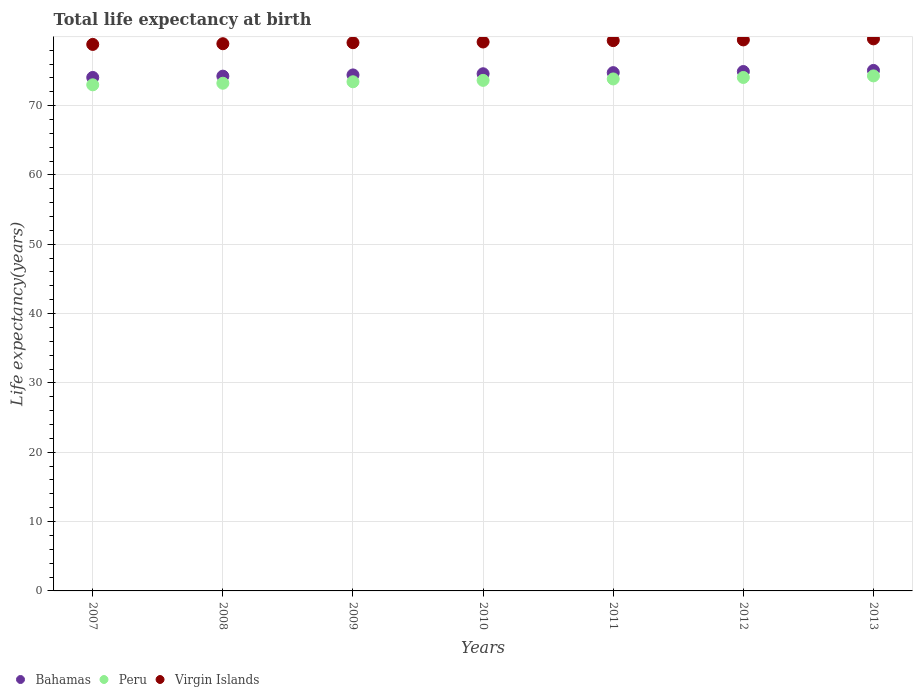How many different coloured dotlines are there?
Your answer should be very brief. 3. Is the number of dotlines equal to the number of legend labels?
Ensure brevity in your answer.  Yes. What is the life expectancy at birth in in Bahamas in 2009?
Offer a very short reply. 74.42. Across all years, what is the maximum life expectancy at birth in in Bahamas?
Your answer should be very brief. 75.07. Across all years, what is the minimum life expectancy at birth in in Bahamas?
Provide a short and direct response. 74.06. In which year was the life expectancy at birth in in Virgin Islands maximum?
Give a very brief answer. 2013. In which year was the life expectancy at birth in in Bahamas minimum?
Offer a very short reply. 2007. What is the total life expectancy at birth in in Bahamas in the graph?
Your answer should be very brief. 522.07. What is the difference between the life expectancy at birth in in Virgin Islands in 2007 and that in 2009?
Your answer should be very brief. -0.25. What is the difference between the life expectancy at birth in in Peru in 2013 and the life expectancy at birth in in Virgin Islands in 2009?
Your response must be concise. -4.79. What is the average life expectancy at birth in in Virgin Islands per year?
Your response must be concise. 79.21. In the year 2008, what is the difference between the life expectancy at birth in in Virgin Islands and life expectancy at birth in in Bahamas?
Offer a very short reply. 4.68. In how many years, is the life expectancy at birth in in Peru greater than 58 years?
Provide a short and direct response. 7. What is the ratio of the life expectancy at birth in in Bahamas in 2007 to that in 2013?
Provide a succinct answer. 0.99. Is the life expectancy at birth in in Bahamas in 2010 less than that in 2013?
Provide a succinct answer. Yes. Is the difference between the life expectancy at birth in in Virgin Islands in 2009 and 2011 greater than the difference between the life expectancy at birth in in Bahamas in 2009 and 2011?
Your response must be concise. Yes. What is the difference between the highest and the second highest life expectancy at birth in in Virgin Islands?
Keep it short and to the point. 0.15. What is the difference between the highest and the lowest life expectancy at birth in in Peru?
Provide a succinct answer. 1.29. Is the sum of the life expectancy at birth in in Virgin Islands in 2009 and 2012 greater than the maximum life expectancy at birth in in Peru across all years?
Your answer should be compact. Yes. Is it the case that in every year, the sum of the life expectancy at birth in in Virgin Islands and life expectancy at birth in in Peru  is greater than the life expectancy at birth in in Bahamas?
Offer a terse response. Yes. Is the life expectancy at birth in in Virgin Islands strictly greater than the life expectancy at birth in in Peru over the years?
Keep it short and to the point. Yes. How many years are there in the graph?
Provide a short and direct response. 7. Are the values on the major ticks of Y-axis written in scientific E-notation?
Your answer should be very brief. No. Does the graph contain any zero values?
Ensure brevity in your answer.  No. Does the graph contain grids?
Provide a short and direct response. Yes. Where does the legend appear in the graph?
Make the answer very short. Bottom left. How many legend labels are there?
Your response must be concise. 3. How are the legend labels stacked?
Offer a terse response. Horizontal. What is the title of the graph?
Make the answer very short. Total life expectancy at birth. Does "Australia" appear as one of the legend labels in the graph?
Give a very brief answer. No. What is the label or title of the Y-axis?
Your answer should be compact. Life expectancy(years). What is the Life expectancy(years) in Bahamas in 2007?
Offer a very short reply. 74.06. What is the Life expectancy(years) of Peru in 2007?
Provide a short and direct response. 73. What is the Life expectancy(years) in Virgin Islands in 2007?
Your answer should be compact. 78.82. What is the Life expectancy(years) in Bahamas in 2008?
Give a very brief answer. 74.25. What is the Life expectancy(years) of Peru in 2008?
Your answer should be very brief. 73.23. What is the Life expectancy(years) of Virgin Islands in 2008?
Your answer should be compact. 78.92. What is the Life expectancy(years) in Bahamas in 2009?
Provide a succinct answer. 74.42. What is the Life expectancy(years) in Peru in 2009?
Give a very brief answer. 73.44. What is the Life expectancy(years) in Virgin Islands in 2009?
Give a very brief answer. 79.07. What is the Life expectancy(years) of Bahamas in 2010?
Offer a very short reply. 74.59. What is the Life expectancy(years) of Peru in 2010?
Ensure brevity in your answer.  73.64. What is the Life expectancy(years) of Virgin Islands in 2010?
Give a very brief answer. 79.17. What is the Life expectancy(years) in Bahamas in 2011?
Keep it short and to the point. 74.75. What is the Life expectancy(years) of Peru in 2011?
Your answer should be very brief. 73.84. What is the Life expectancy(years) in Virgin Islands in 2011?
Give a very brief answer. 79.37. What is the Life expectancy(years) in Bahamas in 2012?
Your answer should be very brief. 74.91. What is the Life expectancy(years) in Peru in 2012?
Give a very brief answer. 74.06. What is the Life expectancy(years) of Virgin Islands in 2012?
Make the answer very short. 79.47. What is the Life expectancy(years) in Bahamas in 2013?
Give a very brief answer. 75.07. What is the Life expectancy(years) of Peru in 2013?
Provide a succinct answer. 74.28. What is the Life expectancy(years) of Virgin Islands in 2013?
Provide a short and direct response. 79.62. Across all years, what is the maximum Life expectancy(years) of Bahamas?
Provide a succinct answer. 75.07. Across all years, what is the maximum Life expectancy(years) of Peru?
Give a very brief answer. 74.28. Across all years, what is the maximum Life expectancy(years) of Virgin Islands?
Give a very brief answer. 79.62. Across all years, what is the minimum Life expectancy(years) in Bahamas?
Your answer should be compact. 74.06. Across all years, what is the minimum Life expectancy(years) of Peru?
Provide a succinct answer. 73. Across all years, what is the minimum Life expectancy(years) of Virgin Islands?
Offer a very short reply. 78.82. What is the total Life expectancy(years) of Bahamas in the graph?
Offer a terse response. 522.07. What is the total Life expectancy(years) in Peru in the graph?
Your answer should be very brief. 515.48. What is the total Life expectancy(years) in Virgin Islands in the graph?
Your answer should be very brief. 554.47. What is the difference between the Life expectancy(years) in Bahamas in 2007 and that in 2008?
Offer a terse response. -0.19. What is the difference between the Life expectancy(years) in Peru in 2007 and that in 2008?
Give a very brief answer. -0.23. What is the difference between the Life expectancy(years) in Virgin Islands in 2007 and that in 2008?
Your answer should be compact. -0.1. What is the difference between the Life expectancy(years) of Bahamas in 2007 and that in 2009?
Provide a short and direct response. -0.36. What is the difference between the Life expectancy(years) in Peru in 2007 and that in 2009?
Ensure brevity in your answer.  -0.44. What is the difference between the Life expectancy(years) of Virgin Islands in 2007 and that in 2009?
Give a very brief answer. -0.25. What is the difference between the Life expectancy(years) of Bahamas in 2007 and that in 2010?
Provide a succinct answer. -0.53. What is the difference between the Life expectancy(years) of Peru in 2007 and that in 2010?
Make the answer very short. -0.64. What is the difference between the Life expectancy(years) of Virgin Islands in 2007 and that in 2010?
Give a very brief answer. -0.35. What is the difference between the Life expectancy(years) of Bahamas in 2007 and that in 2011?
Your answer should be very brief. -0.69. What is the difference between the Life expectancy(years) in Peru in 2007 and that in 2011?
Offer a very short reply. -0.85. What is the difference between the Life expectancy(years) in Virgin Islands in 2007 and that in 2011?
Your answer should be compact. -0.55. What is the difference between the Life expectancy(years) in Bahamas in 2007 and that in 2012?
Your answer should be very brief. -0.85. What is the difference between the Life expectancy(years) of Peru in 2007 and that in 2012?
Your response must be concise. -1.06. What is the difference between the Life expectancy(years) in Virgin Islands in 2007 and that in 2012?
Your answer should be compact. -0.65. What is the difference between the Life expectancy(years) in Bahamas in 2007 and that in 2013?
Give a very brief answer. -1.01. What is the difference between the Life expectancy(years) in Peru in 2007 and that in 2013?
Provide a succinct answer. -1.29. What is the difference between the Life expectancy(years) in Bahamas in 2008 and that in 2009?
Keep it short and to the point. -0.18. What is the difference between the Life expectancy(years) of Peru in 2008 and that in 2009?
Your answer should be very brief. -0.21. What is the difference between the Life expectancy(years) of Virgin Islands in 2008 and that in 2009?
Offer a very short reply. -0.15. What is the difference between the Life expectancy(years) of Bahamas in 2008 and that in 2010?
Ensure brevity in your answer.  -0.34. What is the difference between the Life expectancy(years) in Peru in 2008 and that in 2010?
Your response must be concise. -0.41. What is the difference between the Life expectancy(years) of Virgin Islands in 2008 and that in 2010?
Provide a succinct answer. -0.25. What is the difference between the Life expectancy(years) in Bahamas in 2008 and that in 2011?
Offer a terse response. -0.51. What is the difference between the Life expectancy(years) in Peru in 2008 and that in 2011?
Offer a terse response. -0.62. What is the difference between the Life expectancy(years) of Virgin Islands in 2008 and that in 2011?
Your answer should be compact. -0.45. What is the difference between the Life expectancy(years) in Bahamas in 2008 and that in 2012?
Offer a terse response. -0.67. What is the difference between the Life expectancy(years) in Peru in 2008 and that in 2012?
Offer a terse response. -0.83. What is the difference between the Life expectancy(years) of Virgin Islands in 2008 and that in 2012?
Provide a succinct answer. -0.55. What is the difference between the Life expectancy(years) in Bahamas in 2008 and that in 2013?
Offer a terse response. -0.83. What is the difference between the Life expectancy(years) of Peru in 2008 and that in 2013?
Offer a terse response. -1.06. What is the difference between the Life expectancy(years) in Virgin Islands in 2008 and that in 2013?
Make the answer very short. -0.7. What is the difference between the Life expectancy(years) in Bahamas in 2009 and that in 2010?
Ensure brevity in your answer.  -0.17. What is the difference between the Life expectancy(years) of Peru in 2009 and that in 2010?
Give a very brief answer. -0.2. What is the difference between the Life expectancy(years) in Virgin Islands in 2009 and that in 2010?
Ensure brevity in your answer.  -0.1. What is the difference between the Life expectancy(years) of Bahamas in 2009 and that in 2011?
Give a very brief answer. -0.33. What is the difference between the Life expectancy(years) of Peru in 2009 and that in 2011?
Offer a very short reply. -0.41. What is the difference between the Life expectancy(years) in Virgin Islands in 2009 and that in 2011?
Offer a terse response. -0.3. What is the difference between the Life expectancy(years) in Bahamas in 2009 and that in 2012?
Provide a short and direct response. -0.49. What is the difference between the Life expectancy(years) of Peru in 2009 and that in 2012?
Ensure brevity in your answer.  -0.62. What is the difference between the Life expectancy(years) in Virgin Islands in 2009 and that in 2012?
Keep it short and to the point. -0.4. What is the difference between the Life expectancy(years) in Bahamas in 2009 and that in 2013?
Ensure brevity in your answer.  -0.65. What is the difference between the Life expectancy(years) in Peru in 2009 and that in 2013?
Ensure brevity in your answer.  -0.85. What is the difference between the Life expectancy(years) of Virgin Islands in 2009 and that in 2013?
Your response must be concise. -0.55. What is the difference between the Life expectancy(years) of Bahamas in 2010 and that in 2011?
Offer a very short reply. -0.16. What is the difference between the Life expectancy(years) in Peru in 2010 and that in 2011?
Offer a terse response. -0.21. What is the difference between the Life expectancy(years) of Virgin Islands in 2010 and that in 2011?
Your answer should be compact. -0.2. What is the difference between the Life expectancy(years) in Bahamas in 2010 and that in 2012?
Your answer should be compact. -0.32. What is the difference between the Life expectancy(years) in Peru in 2010 and that in 2012?
Offer a very short reply. -0.42. What is the difference between the Life expectancy(years) of Bahamas in 2010 and that in 2013?
Your response must be concise. -0.48. What is the difference between the Life expectancy(years) in Peru in 2010 and that in 2013?
Your answer should be compact. -0.64. What is the difference between the Life expectancy(years) in Virgin Islands in 2010 and that in 2013?
Your answer should be compact. -0.45. What is the difference between the Life expectancy(years) in Bahamas in 2011 and that in 2012?
Offer a terse response. -0.16. What is the difference between the Life expectancy(years) in Peru in 2011 and that in 2012?
Keep it short and to the point. -0.21. What is the difference between the Life expectancy(years) in Bahamas in 2011 and that in 2013?
Offer a terse response. -0.32. What is the difference between the Life expectancy(years) of Peru in 2011 and that in 2013?
Your answer should be very brief. -0.44. What is the difference between the Life expectancy(years) of Virgin Islands in 2011 and that in 2013?
Ensure brevity in your answer.  -0.25. What is the difference between the Life expectancy(years) of Bahamas in 2012 and that in 2013?
Provide a succinct answer. -0.16. What is the difference between the Life expectancy(years) in Peru in 2012 and that in 2013?
Give a very brief answer. -0.23. What is the difference between the Life expectancy(years) in Virgin Islands in 2012 and that in 2013?
Keep it short and to the point. -0.15. What is the difference between the Life expectancy(years) of Bahamas in 2007 and the Life expectancy(years) of Peru in 2008?
Your answer should be very brief. 0.83. What is the difference between the Life expectancy(years) in Bahamas in 2007 and the Life expectancy(years) in Virgin Islands in 2008?
Give a very brief answer. -4.86. What is the difference between the Life expectancy(years) in Peru in 2007 and the Life expectancy(years) in Virgin Islands in 2008?
Offer a very short reply. -5.93. What is the difference between the Life expectancy(years) of Bahamas in 2007 and the Life expectancy(years) of Peru in 2009?
Your response must be concise. 0.62. What is the difference between the Life expectancy(years) of Bahamas in 2007 and the Life expectancy(years) of Virgin Islands in 2009?
Offer a terse response. -5.01. What is the difference between the Life expectancy(years) of Peru in 2007 and the Life expectancy(years) of Virgin Islands in 2009?
Provide a short and direct response. -6.08. What is the difference between the Life expectancy(years) of Bahamas in 2007 and the Life expectancy(years) of Peru in 2010?
Your response must be concise. 0.42. What is the difference between the Life expectancy(years) in Bahamas in 2007 and the Life expectancy(years) in Virgin Islands in 2010?
Keep it short and to the point. -5.11. What is the difference between the Life expectancy(years) of Peru in 2007 and the Life expectancy(years) of Virgin Islands in 2010?
Keep it short and to the point. -6.18. What is the difference between the Life expectancy(years) of Bahamas in 2007 and the Life expectancy(years) of Peru in 2011?
Ensure brevity in your answer.  0.21. What is the difference between the Life expectancy(years) in Bahamas in 2007 and the Life expectancy(years) in Virgin Islands in 2011?
Keep it short and to the point. -5.31. What is the difference between the Life expectancy(years) in Peru in 2007 and the Life expectancy(years) in Virgin Islands in 2011?
Offer a very short reply. -6.38. What is the difference between the Life expectancy(years) in Bahamas in 2007 and the Life expectancy(years) in Peru in 2012?
Give a very brief answer. 0. What is the difference between the Life expectancy(years) in Bahamas in 2007 and the Life expectancy(years) in Virgin Islands in 2012?
Keep it short and to the point. -5.41. What is the difference between the Life expectancy(years) of Peru in 2007 and the Life expectancy(years) of Virgin Islands in 2012?
Ensure brevity in your answer.  -6.48. What is the difference between the Life expectancy(years) of Bahamas in 2007 and the Life expectancy(years) of Peru in 2013?
Provide a short and direct response. -0.22. What is the difference between the Life expectancy(years) of Bahamas in 2007 and the Life expectancy(years) of Virgin Islands in 2013?
Make the answer very short. -5.56. What is the difference between the Life expectancy(years) in Peru in 2007 and the Life expectancy(years) in Virgin Islands in 2013?
Your answer should be compact. -6.63. What is the difference between the Life expectancy(years) in Bahamas in 2008 and the Life expectancy(years) in Peru in 2009?
Provide a short and direct response. 0.81. What is the difference between the Life expectancy(years) of Bahamas in 2008 and the Life expectancy(years) of Virgin Islands in 2009?
Your answer should be very brief. -4.83. What is the difference between the Life expectancy(years) in Peru in 2008 and the Life expectancy(years) in Virgin Islands in 2009?
Keep it short and to the point. -5.85. What is the difference between the Life expectancy(years) in Bahamas in 2008 and the Life expectancy(years) in Peru in 2010?
Ensure brevity in your answer.  0.61. What is the difference between the Life expectancy(years) of Bahamas in 2008 and the Life expectancy(years) of Virgin Islands in 2010?
Your response must be concise. -4.93. What is the difference between the Life expectancy(years) in Peru in 2008 and the Life expectancy(years) in Virgin Islands in 2010?
Provide a succinct answer. -5.95. What is the difference between the Life expectancy(years) in Bahamas in 2008 and the Life expectancy(years) in Peru in 2011?
Offer a terse response. 0.4. What is the difference between the Life expectancy(years) of Bahamas in 2008 and the Life expectancy(years) of Virgin Islands in 2011?
Provide a succinct answer. -5.13. What is the difference between the Life expectancy(years) in Peru in 2008 and the Life expectancy(years) in Virgin Islands in 2011?
Give a very brief answer. -6.15. What is the difference between the Life expectancy(years) in Bahamas in 2008 and the Life expectancy(years) in Peru in 2012?
Provide a short and direct response. 0.19. What is the difference between the Life expectancy(years) in Bahamas in 2008 and the Life expectancy(years) in Virgin Islands in 2012?
Keep it short and to the point. -5.23. What is the difference between the Life expectancy(years) of Peru in 2008 and the Life expectancy(years) of Virgin Islands in 2012?
Give a very brief answer. -6.25. What is the difference between the Life expectancy(years) of Bahamas in 2008 and the Life expectancy(years) of Peru in 2013?
Give a very brief answer. -0.04. What is the difference between the Life expectancy(years) of Bahamas in 2008 and the Life expectancy(years) of Virgin Islands in 2013?
Your answer should be very brief. -5.38. What is the difference between the Life expectancy(years) of Peru in 2008 and the Life expectancy(years) of Virgin Islands in 2013?
Provide a succinct answer. -6.4. What is the difference between the Life expectancy(years) of Bahamas in 2009 and the Life expectancy(years) of Peru in 2010?
Your response must be concise. 0.78. What is the difference between the Life expectancy(years) in Bahamas in 2009 and the Life expectancy(years) in Virgin Islands in 2010?
Your answer should be very brief. -4.75. What is the difference between the Life expectancy(years) of Peru in 2009 and the Life expectancy(years) of Virgin Islands in 2010?
Give a very brief answer. -5.74. What is the difference between the Life expectancy(years) of Bahamas in 2009 and the Life expectancy(years) of Peru in 2011?
Your answer should be compact. 0.58. What is the difference between the Life expectancy(years) of Bahamas in 2009 and the Life expectancy(years) of Virgin Islands in 2011?
Your response must be concise. -4.95. What is the difference between the Life expectancy(years) in Peru in 2009 and the Life expectancy(years) in Virgin Islands in 2011?
Provide a short and direct response. -5.94. What is the difference between the Life expectancy(years) of Bahamas in 2009 and the Life expectancy(years) of Peru in 2012?
Ensure brevity in your answer.  0.37. What is the difference between the Life expectancy(years) of Bahamas in 2009 and the Life expectancy(years) of Virgin Islands in 2012?
Offer a very short reply. -5.05. What is the difference between the Life expectancy(years) of Peru in 2009 and the Life expectancy(years) of Virgin Islands in 2012?
Provide a succinct answer. -6.04. What is the difference between the Life expectancy(years) in Bahamas in 2009 and the Life expectancy(years) in Peru in 2013?
Offer a very short reply. 0.14. What is the difference between the Life expectancy(years) of Bahamas in 2009 and the Life expectancy(years) of Virgin Islands in 2013?
Offer a terse response. -5.2. What is the difference between the Life expectancy(years) of Peru in 2009 and the Life expectancy(years) of Virgin Islands in 2013?
Your answer should be very brief. -6.19. What is the difference between the Life expectancy(years) of Bahamas in 2010 and the Life expectancy(years) of Peru in 2011?
Provide a short and direct response. 0.75. What is the difference between the Life expectancy(years) of Bahamas in 2010 and the Life expectancy(years) of Virgin Islands in 2011?
Ensure brevity in your answer.  -4.78. What is the difference between the Life expectancy(years) of Peru in 2010 and the Life expectancy(years) of Virgin Islands in 2011?
Keep it short and to the point. -5.73. What is the difference between the Life expectancy(years) in Bahamas in 2010 and the Life expectancy(years) in Peru in 2012?
Make the answer very short. 0.53. What is the difference between the Life expectancy(years) in Bahamas in 2010 and the Life expectancy(years) in Virgin Islands in 2012?
Make the answer very short. -4.88. What is the difference between the Life expectancy(years) in Peru in 2010 and the Life expectancy(years) in Virgin Islands in 2012?
Your response must be concise. -5.83. What is the difference between the Life expectancy(years) in Bahamas in 2010 and the Life expectancy(years) in Peru in 2013?
Ensure brevity in your answer.  0.31. What is the difference between the Life expectancy(years) of Bahamas in 2010 and the Life expectancy(years) of Virgin Islands in 2013?
Your answer should be very brief. -5.03. What is the difference between the Life expectancy(years) of Peru in 2010 and the Life expectancy(years) of Virgin Islands in 2013?
Provide a short and direct response. -5.98. What is the difference between the Life expectancy(years) of Bahamas in 2011 and the Life expectancy(years) of Peru in 2012?
Offer a very short reply. 0.7. What is the difference between the Life expectancy(years) of Bahamas in 2011 and the Life expectancy(years) of Virgin Islands in 2012?
Your response must be concise. -4.72. What is the difference between the Life expectancy(years) in Peru in 2011 and the Life expectancy(years) in Virgin Islands in 2012?
Make the answer very short. -5.63. What is the difference between the Life expectancy(years) of Bahamas in 2011 and the Life expectancy(years) of Peru in 2013?
Provide a short and direct response. 0.47. What is the difference between the Life expectancy(years) in Bahamas in 2011 and the Life expectancy(years) in Virgin Islands in 2013?
Give a very brief answer. -4.87. What is the difference between the Life expectancy(years) of Peru in 2011 and the Life expectancy(years) of Virgin Islands in 2013?
Give a very brief answer. -5.78. What is the difference between the Life expectancy(years) of Bahamas in 2012 and the Life expectancy(years) of Peru in 2013?
Offer a very short reply. 0.63. What is the difference between the Life expectancy(years) of Bahamas in 2012 and the Life expectancy(years) of Virgin Islands in 2013?
Your answer should be very brief. -4.71. What is the difference between the Life expectancy(years) of Peru in 2012 and the Life expectancy(years) of Virgin Islands in 2013?
Offer a terse response. -5.57. What is the average Life expectancy(years) in Bahamas per year?
Keep it short and to the point. 74.58. What is the average Life expectancy(years) of Peru per year?
Keep it short and to the point. 73.64. What is the average Life expectancy(years) in Virgin Islands per year?
Offer a very short reply. 79.21. In the year 2007, what is the difference between the Life expectancy(years) of Bahamas and Life expectancy(years) of Virgin Islands?
Provide a short and direct response. -4.76. In the year 2007, what is the difference between the Life expectancy(years) in Peru and Life expectancy(years) in Virgin Islands?
Provide a succinct answer. -5.83. In the year 2008, what is the difference between the Life expectancy(years) in Bahamas and Life expectancy(years) in Peru?
Keep it short and to the point. 1.02. In the year 2008, what is the difference between the Life expectancy(years) of Bahamas and Life expectancy(years) of Virgin Islands?
Your response must be concise. -4.68. In the year 2008, what is the difference between the Life expectancy(years) in Peru and Life expectancy(years) in Virgin Islands?
Offer a very short reply. -5.7. In the year 2009, what is the difference between the Life expectancy(years) of Bahamas and Life expectancy(years) of Virgin Islands?
Give a very brief answer. -4.65. In the year 2009, what is the difference between the Life expectancy(years) in Peru and Life expectancy(years) in Virgin Islands?
Your response must be concise. -5.64. In the year 2010, what is the difference between the Life expectancy(years) of Bahamas and Life expectancy(years) of Peru?
Provide a short and direct response. 0.95. In the year 2010, what is the difference between the Life expectancy(years) in Bahamas and Life expectancy(years) in Virgin Islands?
Keep it short and to the point. -4.58. In the year 2010, what is the difference between the Life expectancy(years) of Peru and Life expectancy(years) of Virgin Islands?
Your answer should be compact. -5.53. In the year 2011, what is the difference between the Life expectancy(years) in Bahamas and Life expectancy(years) in Peru?
Make the answer very short. 0.91. In the year 2011, what is the difference between the Life expectancy(years) of Bahamas and Life expectancy(years) of Virgin Islands?
Your answer should be compact. -4.62. In the year 2011, what is the difference between the Life expectancy(years) of Peru and Life expectancy(years) of Virgin Islands?
Make the answer very short. -5.53. In the year 2012, what is the difference between the Life expectancy(years) of Bahamas and Life expectancy(years) of Peru?
Give a very brief answer. 0.86. In the year 2012, what is the difference between the Life expectancy(years) in Bahamas and Life expectancy(years) in Virgin Islands?
Your answer should be compact. -4.56. In the year 2012, what is the difference between the Life expectancy(years) of Peru and Life expectancy(years) of Virgin Islands?
Ensure brevity in your answer.  -5.42. In the year 2013, what is the difference between the Life expectancy(years) of Bahamas and Life expectancy(years) of Peru?
Make the answer very short. 0.79. In the year 2013, what is the difference between the Life expectancy(years) of Bahamas and Life expectancy(years) of Virgin Islands?
Provide a short and direct response. -4.55. In the year 2013, what is the difference between the Life expectancy(years) in Peru and Life expectancy(years) in Virgin Islands?
Ensure brevity in your answer.  -5.34. What is the ratio of the Life expectancy(years) in Bahamas in 2007 to that in 2008?
Keep it short and to the point. 1. What is the ratio of the Life expectancy(years) of Peru in 2007 to that in 2009?
Give a very brief answer. 0.99. What is the ratio of the Life expectancy(years) in Virgin Islands in 2007 to that in 2009?
Keep it short and to the point. 1. What is the ratio of the Life expectancy(years) of Peru in 2007 to that in 2010?
Offer a very short reply. 0.99. What is the ratio of the Life expectancy(years) of Peru in 2007 to that in 2011?
Ensure brevity in your answer.  0.99. What is the ratio of the Life expectancy(years) in Bahamas in 2007 to that in 2012?
Ensure brevity in your answer.  0.99. What is the ratio of the Life expectancy(years) in Peru in 2007 to that in 2012?
Give a very brief answer. 0.99. What is the ratio of the Life expectancy(years) of Bahamas in 2007 to that in 2013?
Your answer should be very brief. 0.99. What is the ratio of the Life expectancy(years) in Peru in 2007 to that in 2013?
Give a very brief answer. 0.98. What is the ratio of the Life expectancy(years) of Virgin Islands in 2007 to that in 2013?
Your answer should be compact. 0.99. What is the ratio of the Life expectancy(years) in Bahamas in 2008 to that in 2009?
Ensure brevity in your answer.  1. What is the ratio of the Life expectancy(years) of Peru in 2008 to that in 2009?
Provide a succinct answer. 1. What is the ratio of the Life expectancy(years) of Peru in 2008 to that in 2010?
Offer a terse response. 0.99. What is the ratio of the Life expectancy(years) in Peru in 2008 to that in 2011?
Provide a short and direct response. 0.99. What is the ratio of the Life expectancy(years) of Peru in 2008 to that in 2012?
Your answer should be very brief. 0.99. What is the ratio of the Life expectancy(years) of Virgin Islands in 2008 to that in 2012?
Make the answer very short. 0.99. What is the ratio of the Life expectancy(years) in Bahamas in 2008 to that in 2013?
Offer a terse response. 0.99. What is the ratio of the Life expectancy(years) in Peru in 2008 to that in 2013?
Keep it short and to the point. 0.99. What is the ratio of the Life expectancy(years) of Bahamas in 2009 to that in 2010?
Give a very brief answer. 1. What is the ratio of the Life expectancy(years) of Peru in 2009 to that in 2010?
Provide a succinct answer. 1. What is the ratio of the Life expectancy(years) in Virgin Islands in 2009 to that in 2010?
Keep it short and to the point. 1. What is the ratio of the Life expectancy(years) of Bahamas in 2009 to that in 2011?
Give a very brief answer. 1. What is the ratio of the Life expectancy(years) of Virgin Islands in 2009 to that in 2012?
Ensure brevity in your answer.  0.99. What is the ratio of the Life expectancy(years) of Bahamas in 2009 to that in 2013?
Give a very brief answer. 0.99. What is the ratio of the Life expectancy(years) of Peru in 2009 to that in 2013?
Keep it short and to the point. 0.99. What is the ratio of the Life expectancy(years) of Virgin Islands in 2009 to that in 2013?
Offer a very short reply. 0.99. What is the ratio of the Life expectancy(years) of Peru in 2010 to that in 2011?
Make the answer very short. 1. What is the ratio of the Life expectancy(years) of Virgin Islands in 2010 to that in 2011?
Give a very brief answer. 1. What is the ratio of the Life expectancy(years) of Bahamas in 2010 to that in 2012?
Your answer should be very brief. 1. What is the ratio of the Life expectancy(years) of Peru in 2010 to that in 2012?
Your answer should be compact. 0.99. What is the ratio of the Life expectancy(years) of Virgin Islands in 2010 to that in 2012?
Give a very brief answer. 1. What is the ratio of the Life expectancy(years) in Bahamas in 2010 to that in 2013?
Your response must be concise. 0.99. What is the ratio of the Life expectancy(years) of Virgin Islands in 2010 to that in 2013?
Offer a terse response. 0.99. What is the ratio of the Life expectancy(years) of Virgin Islands in 2012 to that in 2013?
Offer a terse response. 1. What is the difference between the highest and the second highest Life expectancy(years) in Bahamas?
Your answer should be very brief. 0.16. What is the difference between the highest and the second highest Life expectancy(years) of Peru?
Keep it short and to the point. 0.23. What is the difference between the highest and the second highest Life expectancy(years) in Virgin Islands?
Give a very brief answer. 0.15. What is the difference between the highest and the lowest Life expectancy(years) of Bahamas?
Your response must be concise. 1.01. What is the difference between the highest and the lowest Life expectancy(years) in Peru?
Keep it short and to the point. 1.29. 